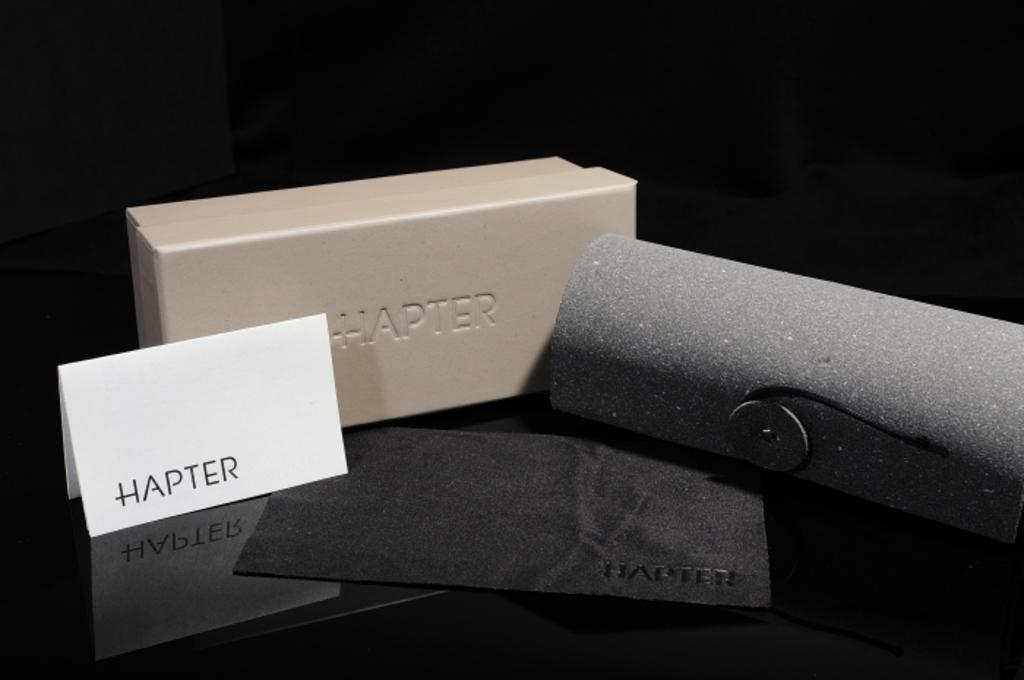Provide a one-sentence caption for the provided image. A HAPTER piece of furnishing is attached to a stone wall. 